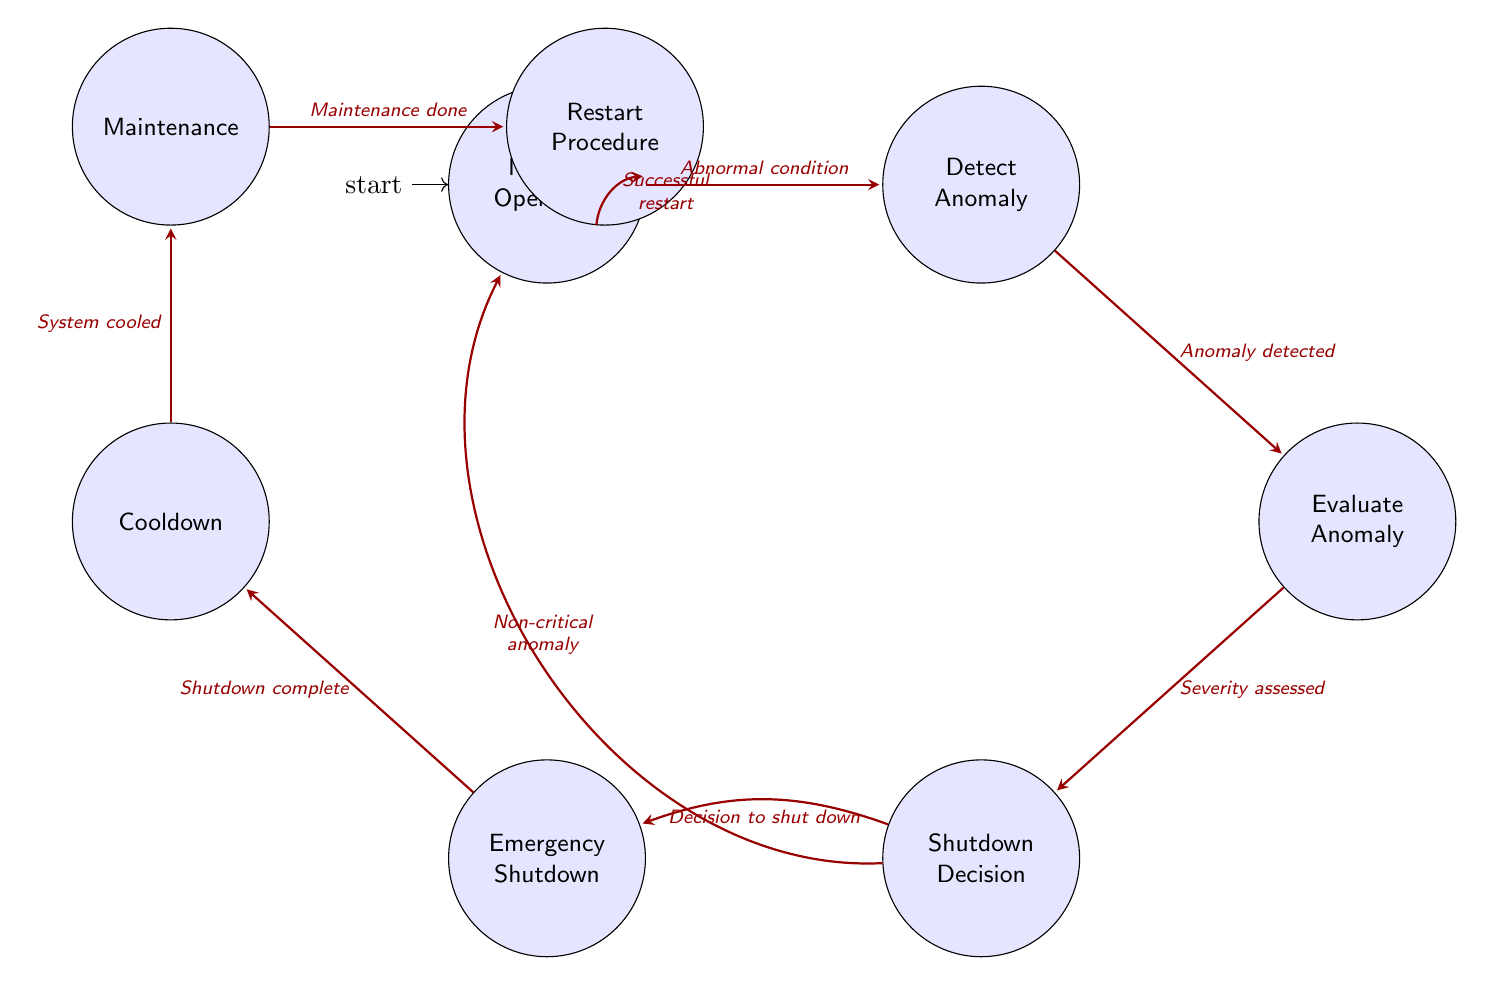what is the initial state of the system? The initial state is labeled as "Normal Operation." This can be identified as the starting point of the finite state machine, which is the first state represented in the diagram.
Answer: Normal Operation how many states are represented in the diagram? By counting each unique state listed in the provided data, we find a total of 8 states: Normal Operation, Detect Anomaly, Evaluate Anomaly, Shutdown Decision, Emergency Shutdown, Cooldown, Maintenance, and Restart Procedure.
Answer: 8 which state follows after an anomaly is detected? After an anomaly is detected, the system transitions to the "Evaluate Anomaly" state. This is indicated by the transition labeled "Anomaly detected" that leads from Detect Anomaly to Evaluate Anomaly.
Answer: Evaluate Anomaly what is the condition to transition from the "Shutdown Decision" state to "Emergency Shutdown"? The condition for transitioning from "Shutdown Decision" to "Emergency Shutdown" is labeled as "Decision to shut down," indicating that a decision has been made to initiate the emergency shutdown.
Answer: Decision to shut down what happens after the system completes the emergency shutdown? After the emergency shutdown is complete, the system transitions to the "Cooldown" state, as indicated by the transition labeled "Shutdown complete." This shows the sequence of actions following the emergency shutdown.
Answer: Cooldown what are the possible outcomes after the "Shutdown Decision" state? The possible outcomes after "Shutdown Decision" are either transitioning to "Emergency Shutdown" with the condition "Decision to shut down" or transitioning back to "Normal Operation" if the anomaly is considered non-critical as indicated by "Anomaly considered non-critical."
Answer: Emergency Shutdown or Normal Operation what is the last state before returning to "Normal Operation"? The last state before returning to "Normal Operation" is "Restart Procedure." This is the final step where the system undergoes a procedure to bring it back to normal functioning after maintenance.
Answer: Restart Procedure what triggers the transition to "Maintenance"? The transition to "Maintenance" is triggered when the "Cooldown" state is completed, as indicated by the condition "System has cooled down." This condition must be fulfilled for the next step to occur.
Answer: System has cooled down 